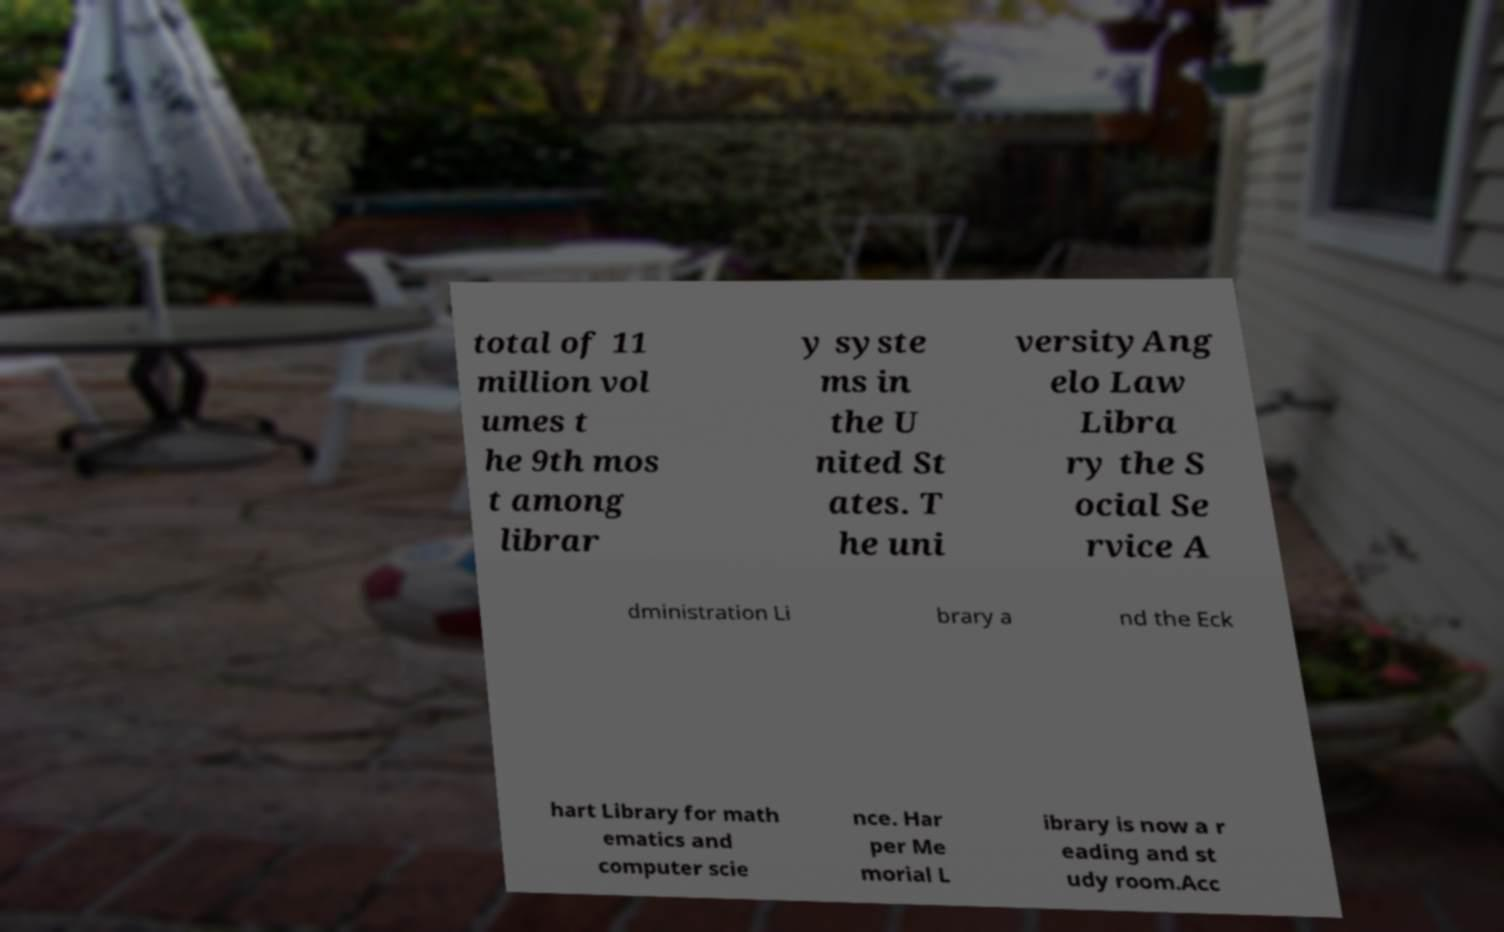There's text embedded in this image that I need extracted. Can you transcribe it verbatim? total of 11 million vol umes t he 9th mos t among librar y syste ms in the U nited St ates. T he uni versityAng elo Law Libra ry the S ocial Se rvice A dministration Li brary a nd the Eck hart Library for math ematics and computer scie nce. Har per Me morial L ibrary is now a r eading and st udy room.Acc 